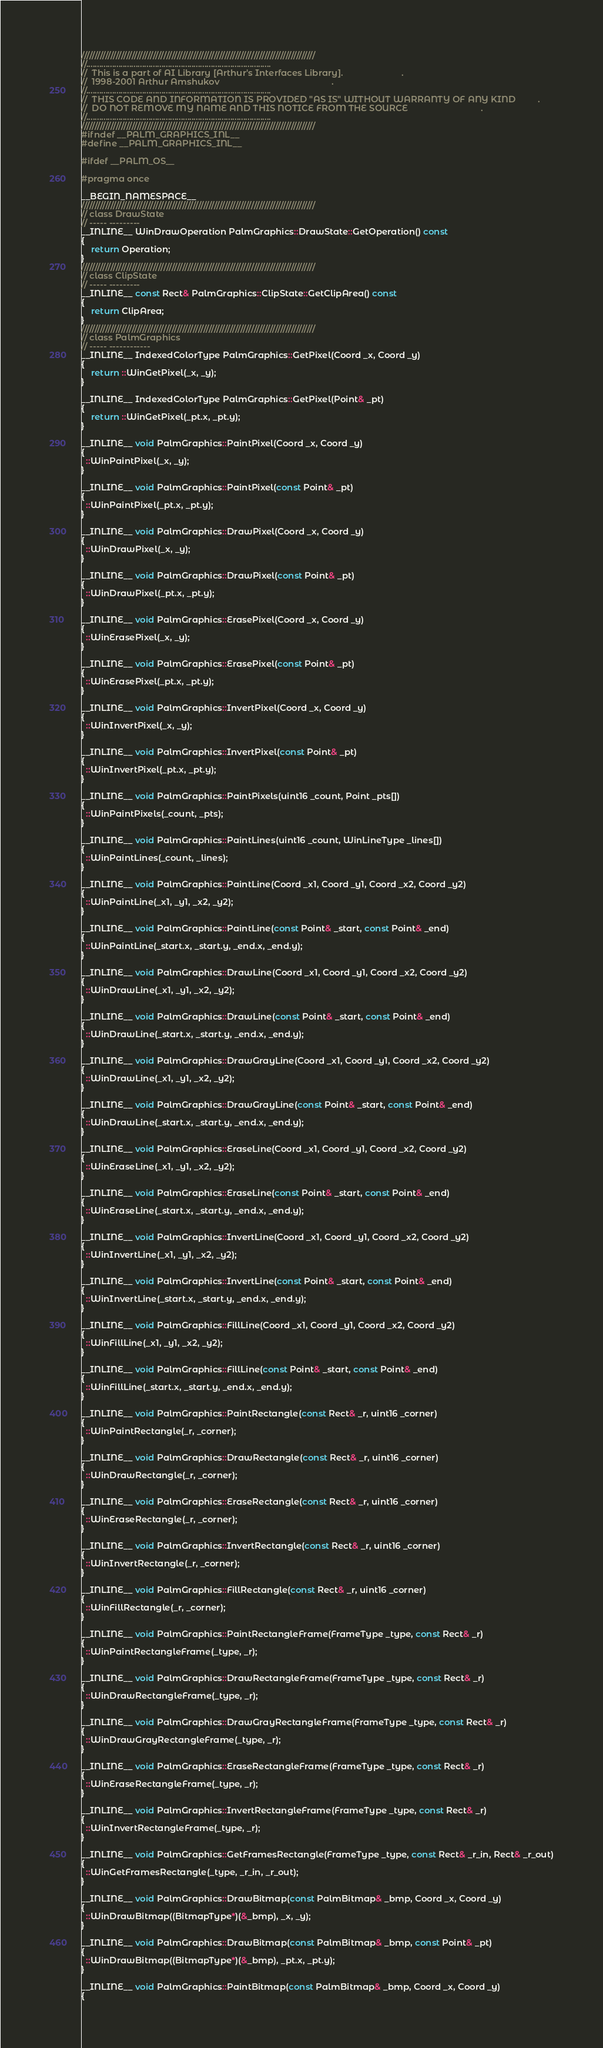<code> <loc_0><loc_0><loc_500><loc_500><_C++_>////////////////////////////////////////////////////////////////////////////////////////
//......................................................................................
//  This is a part of AI Library [Arthur's Interfaces Library].                        .
//  1998-2001 Arthur Amshukov                                              .
//......................................................................................
//  THIS CODE AND INFORMATION IS PROVIDED "AS IS" WITHOUT WARRANTY OF ANY KIND         .
//  DO NOT REMOVE MY NAME AND THIS NOTICE FROM THE SOURCE                              .
//......................................................................................
////////////////////////////////////////////////////////////////////////////////////////
#ifndef __PALM_GRAPHICS_INL__
#define __PALM_GRAPHICS_INL__

#ifdef __PALM_OS__

#pragma once

__BEGIN_NAMESPACE__
////////////////////////////////////////////////////////////////////////////////////////
// class DrawState
// ----- ---------
__INLINE__ WinDrawOperation PalmGraphics::DrawState::GetOperation() const
{
    return Operation;
}
////////////////////////////////////////////////////////////////////////////////////////
// class ClipState
// ----- ---------
__INLINE__ const Rect& PalmGraphics::ClipState::GetClipArea() const
{
    return ClipArea;
}
////////////////////////////////////////////////////////////////////////////////////////
// class PalmGraphics
// ----- ------------
__INLINE__ IndexedColorType PalmGraphics::GetPixel(Coord _x, Coord _y)
{
    return ::WinGetPixel(_x, _y);
}

__INLINE__ IndexedColorType PalmGraphics::GetPixel(Point& _pt)
{
    return ::WinGetPixel(_pt.x, _pt.y);
}

__INLINE__ void PalmGraphics::PaintPixel(Coord _x, Coord _y)
{
  ::WinPaintPixel(_x, _y);
}

__INLINE__ void PalmGraphics::PaintPixel(const Point& _pt)
{
  ::WinPaintPixel(_pt.x, _pt.y);
}

__INLINE__ void PalmGraphics::DrawPixel(Coord _x, Coord _y)
{
  ::WinDrawPixel(_x, _y);
}

__INLINE__ void PalmGraphics::DrawPixel(const Point& _pt)
{
  ::WinDrawPixel(_pt.x, _pt.y);
}

__INLINE__ void PalmGraphics::ErasePixel(Coord _x, Coord _y)
{
  ::WinErasePixel(_x, _y);
}

__INLINE__ void PalmGraphics::ErasePixel(const Point& _pt)
{
  ::WinErasePixel(_pt.x, _pt.y);
}

__INLINE__ void PalmGraphics::InvertPixel(Coord _x, Coord _y)
{
  ::WinInvertPixel(_x, _y);
}

__INLINE__ void PalmGraphics::InvertPixel(const Point& _pt)
{
  ::WinInvertPixel(_pt.x, _pt.y);
}

__INLINE__ void PalmGraphics::PaintPixels(uint16 _count, Point _pts[])
{
  ::WinPaintPixels(_count, _pts);
}

__INLINE__ void PalmGraphics::PaintLines(uint16 _count, WinLineType _lines[])
{
  ::WinPaintLines(_count, _lines);
}

__INLINE__ void PalmGraphics::PaintLine(Coord _x1, Coord _y1, Coord _x2, Coord _y2)
{
  ::WinPaintLine(_x1, _y1, _x2, _y2);
}

__INLINE__ void PalmGraphics::PaintLine(const Point& _start, const Point& _end)
{
  ::WinPaintLine(_start.x, _start.y, _end.x, _end.y);
}

__INLINE__ void PalmGraphics::DrawLine(Coord _x1, Coord _y1, Coord _x2, Coord _y2)
{
  ::WinDrawLine(_x1, _y1, _x2, _y2);
}

__INLINE__ void PalmGraphics::DrawLine(const Point& _start, const Point& _end)
{
  ::WinDrawLine(_start.x, _start.y, _end.x, _end.y);
}

__INLINE__ void PalmGraphics::DrawGrayLine(Coord _x1, Coord _y1, Coord _x2, Coord _y2)
{
  ::WinDrawLine(_x1, _y1, _x2, _y2);
}

__INLINE__ void PalmGraphics::DrawGrayLine(const Point& _start, const Point& _end)
{
  ::WinDrawLine(_start.x, _start.y, _end.x, _end.y);
}

__INLINE__ void PalmGraphics::EraseLine(Coord _x1, Coord _y1, Coord _x2, Coord _y2)
{
  ::WinEraseLine(_x1, _y1, _x2, _y2);
}

__INLINE__ void PalmGraphics::EraseLine(const Point& _start, const Point& _end)
{
  ::WinEraseLine(_start.x, _start.y, _end.x, _end.y);
}

__INLINE__ void PalmGraphics::InvertLine(Coord _x1, Coord _y1, Coord _x2, Coord _y2)
{
  ::WinInvertLine(_x1, _y1, _x2, _y2);
}

__INLINE__ void PalmGraphics::InvertLine(const Point& _start, const Point& _end)
{
  ::WinInvertLine(_start.x, _start.y, _end.x, _end.y);
}

__INLINE__ void PalmGraphics::FillLine(Coord _x1, Coord _y1, Coord _x2, Coord _y2)
{
  ::WinFillLine(_x1, _y1, _x2, _y2);
}

__INLINE__ void PalmGraphics::FillLine(const Point& _start, const Point& _end)
{
  ::WinFillLine(_start.x, _start.y, _end.x, _end.y);
}

__INLINE__ void PalmGraphics::PaintRectangle(const Rect& _r, uint16 _corner)
{
  ::WinPaintRectangle(_r, _corner);
}

__INLINE__ void PalmGraphics::DrawRectangle(const Rect& _r, uint16 _corner)
{
  ::WinDrawRectangle(_r, _corner);
}

__INLINE__ void PalmGraphics::EraseRectangle(const Rect& _r, uint16 _corner)
{
  ::WinEraseRectangle(_r, _corner);
}

__INLINE__ void PalmGraphics::InvertRectangle(const Rect& _r, uint16 _corner)
{
  ::WinInvertRectangle(_r, _corner);
}

__INLINE__ void PalmGraphics::FillRectangle(const Rect& _r, uint16 _corner)
{
  ::WinFillRectangle(_r, _corner);
}

__INLINE__ void PalmGraphics::PaintRectangleFrame(FrameType _type, const Rect& _r)
{
  ::WinPaintRectangleFrame(_type, _r);
}

__INLINE__ void PalmGraphics::DrawRectangleFrame(FrameType _type, const Rect& _r)
{
  ::WinDrawRectangleFrame(_type, _r);
}

__INLINE__ void PalmGraphics::DrawGrayRectangleFrame(FrameType _type, const Rect& _r)
{
  ::WinDrawGrayRectangleFrame(_type, _r);
}

__INLINE__ void PalmGraphics::EraseRectangleFrame(FrameType _type, const Rect& _r)
{
  ::WinEraseRectangleFrame(_type, _r);
}

__INLINE__ void PalmGraphics::InvertRectangleFrame(FrameType _type, const Rect& _r)
{
  ::WinInvertRectangleFrame(_type, _r);
}

__INLINE__ void PalmGraphics::GetFramesRectangle(FrameType _type, const Rect& _r_in, Rect& _r_out)
{
  ::WinGetFramesRectangle(_type, _r_in, _r_out);
}

__INLINE__ void PalmGraphics::DrawBitmap(const PalmBitmap& _bmp, Coord _x, Coord _y)
{
  ::WinDrawBitmap((BitmapType*)(&_bmp), _x, _y);
}

__INLINE__ void PalmGraphics::DrawBitmap(const PalmBitmap& _bmp, const Point& _pt)
{
  ::WinDrawBitmap((BitmapType*)(&_bmp), _pt.x, _pt.y);
}

__INLINE__ void PalmGraphics::PaintBitmap(const PalmBitmap& _bmp, Coord _x, Coord _y)
{</code> 